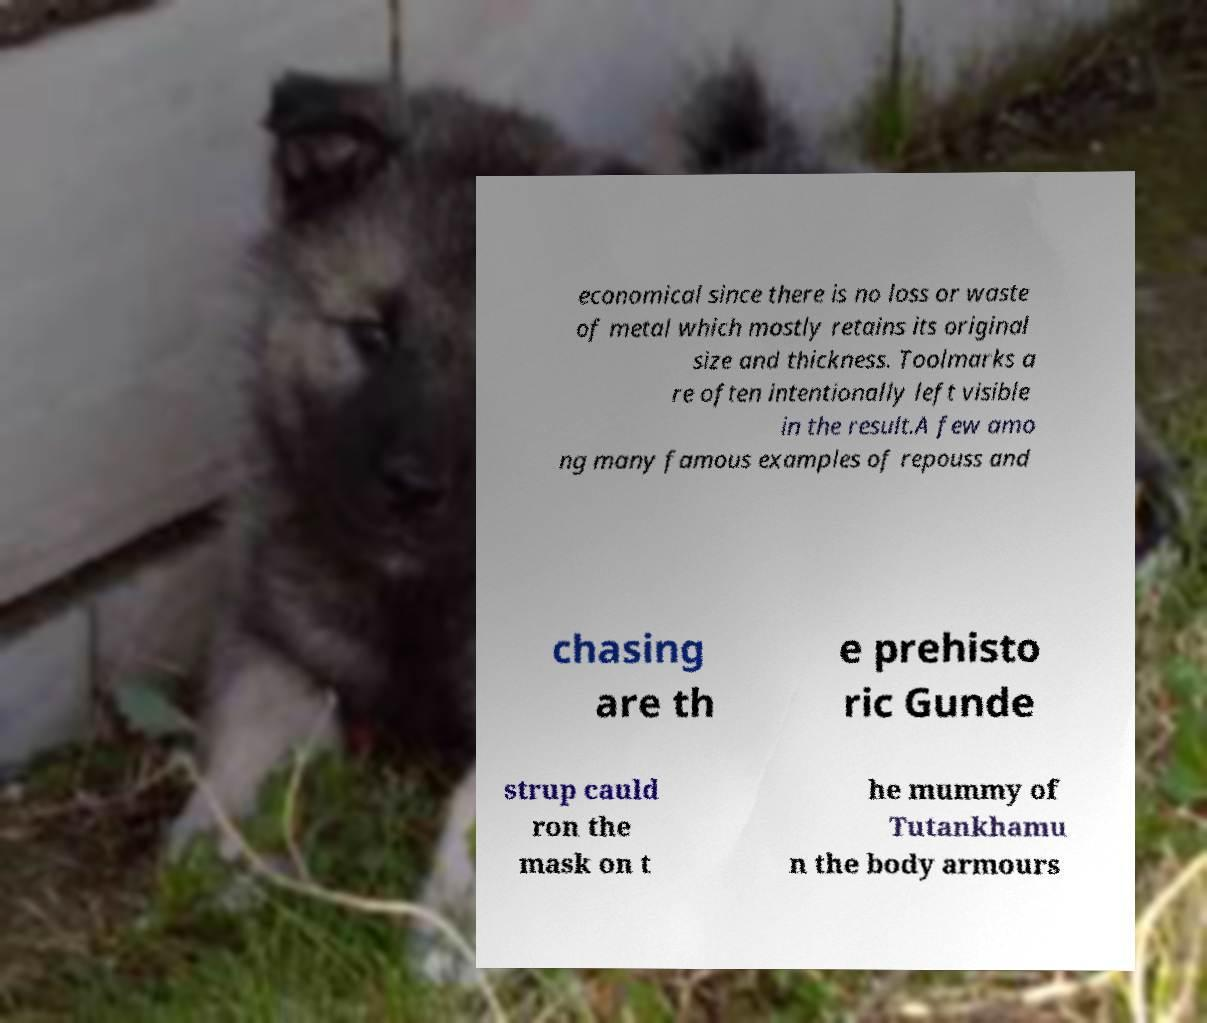Can you accurately transcribe the text from the provided image for me? economical since there is no loss or waste of metal which mostly retains its original size and thickness. Toolmarks a re often intentionally left visible in the result.A few amo ng many famous examples of repouss and chasing are th e prehisto ric Gunde strup cauld ron the mask on t he mummy of Tutankhamu n the body armours 